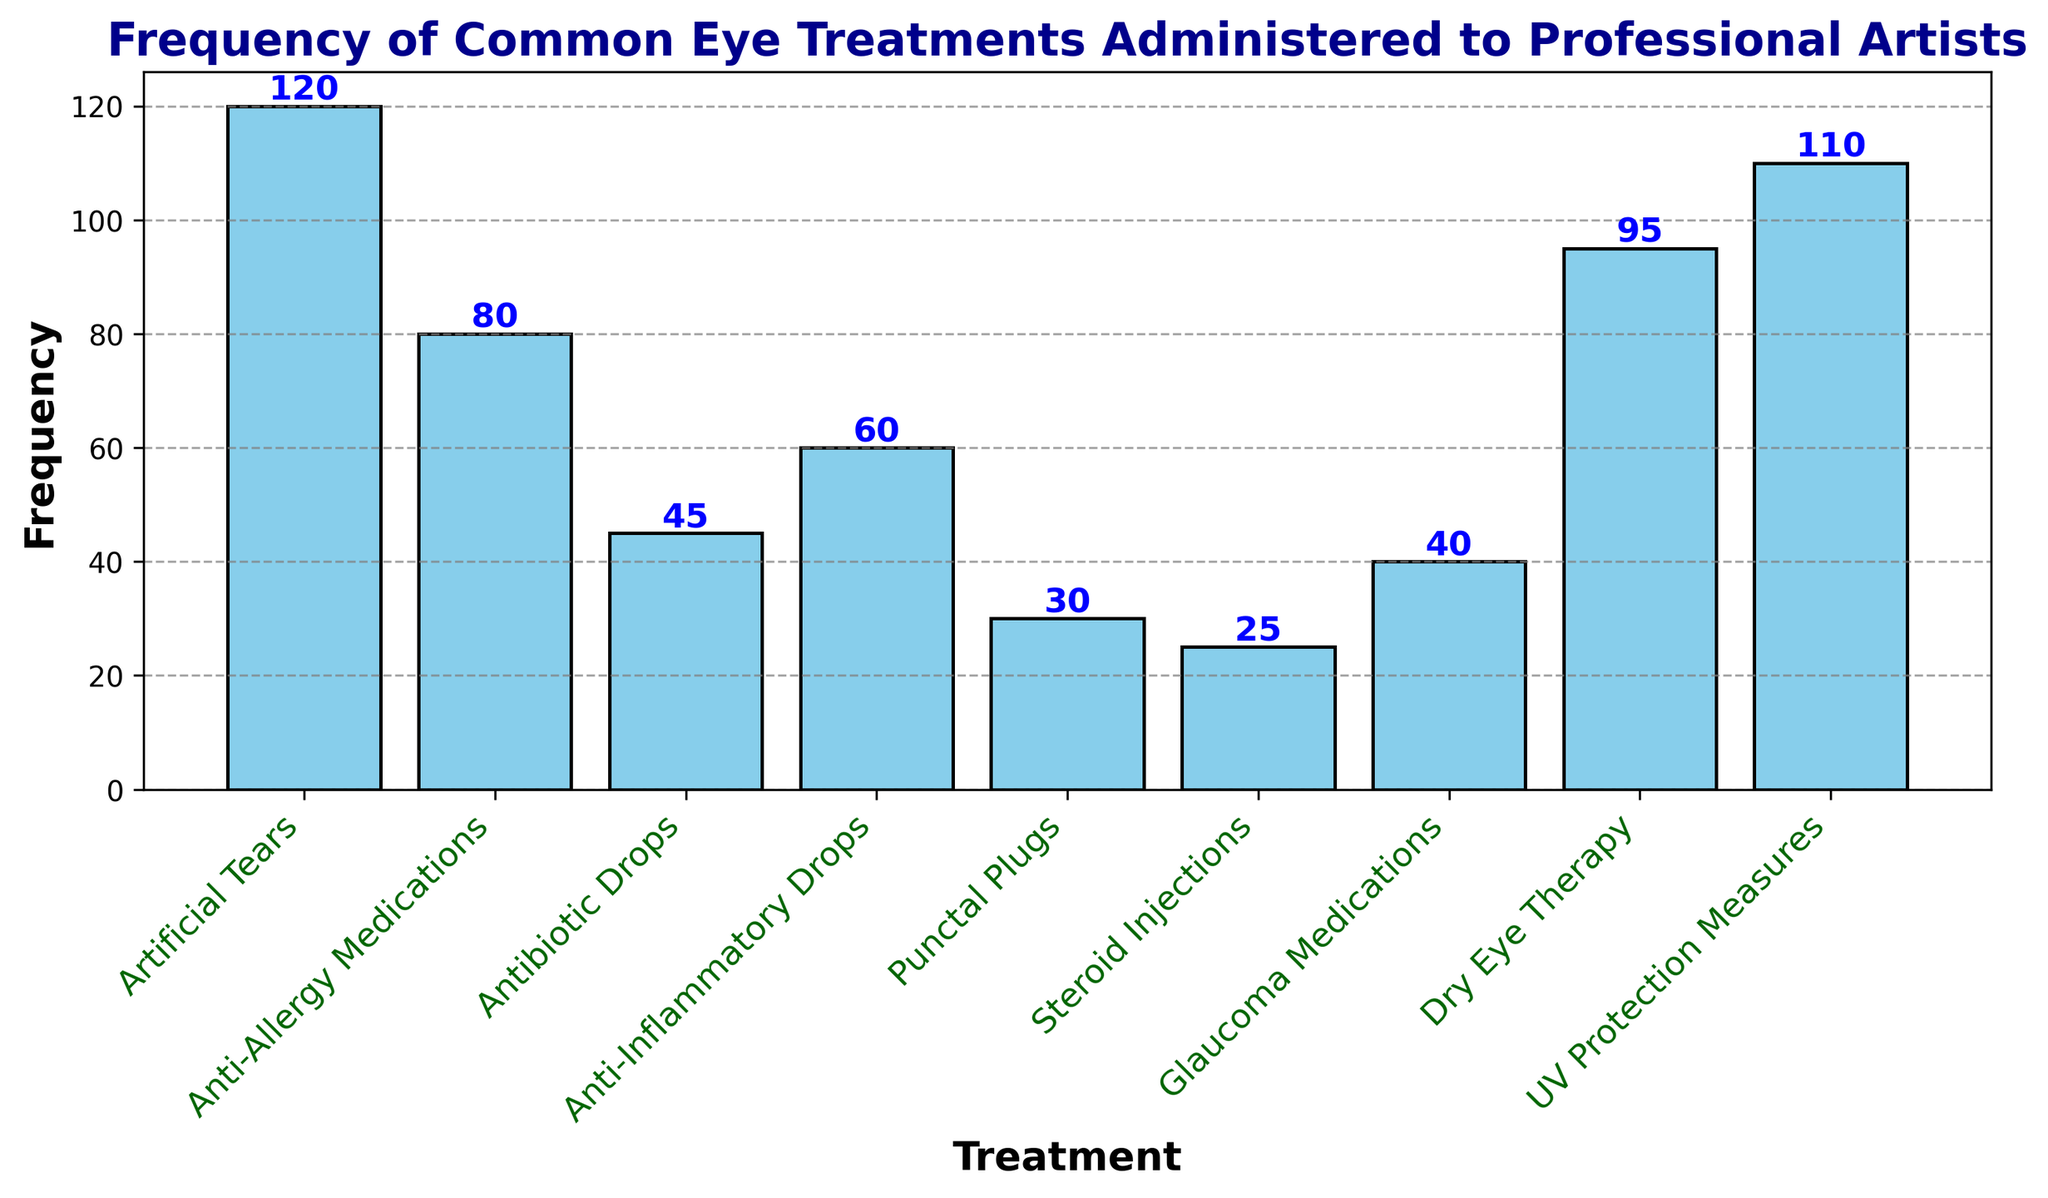Which treatment is administered most frequently? The bar representing "Artificial Tears" is the tallest, indicating it has the highest frequency.
Answer: Artificial Tears Which treatment comes second in terms of frequency? The bar for "UV Protection Measures" is the second tallest, indicating it has the second highest frequency.
Answer: UV Protection Measures What is the combined frequency of Anti-Allergy Medications and Glaucoma Medications? The frequency of Anti-Allergy Medications is 80, and Glaucoma Medications is 40. Adding these together gives us 80 + 40 = 120.
Answer: 120 Is the frequency of Dry Eye Therapy greater than or less than the frequency of Anti-Inflammatory Drops? The bar for Dry Eye Therapy is taller than the bar for Anti-Inflammatory Drops, indicating a greater frequency.
Answer: Greater How many treatments have a frequency greater than or equal to 100? "Artificial Tears" and "UV Protection Measures" both have frequencies above 100. Hence there are 2 such treatments.
Answer: 2 What is the difference in frequency between the most and least administered treatments? The highest frequency is for "Artificial Tears" at 120 and the lowest is for "Steroid Injections" at 25. The difference is 120 - 25 = 95.
Answer: 95 Are there more treatments with a frequency above 50 or below 50? Treatments above 50 are Artificial Tears, Dry Eye Therapy, UV Protection Measures, Anti-Allergy Medications, and Anti-Inflammatory Drops (total 5). Below 50 are Antibiotic Drops, Punctal Plugs, Steroid Injections, and Glaucoma Medications (total 4).
Answer: Above 50 What is the average frequency of the three least administered treatments? The three least frequent treatments are Steroid Injections (25), Punctal Plugs (30), and Antibiotic Drops (45). The sum is 25 + 30 + 45 = 100. The average is 100 / 3 = 33.33.
Answer: 33.33 How many treatments have a frequency exactly equal to 45? Only the bar for "Antibiotic Drops" has a frequency of 45.
Answer: 1 